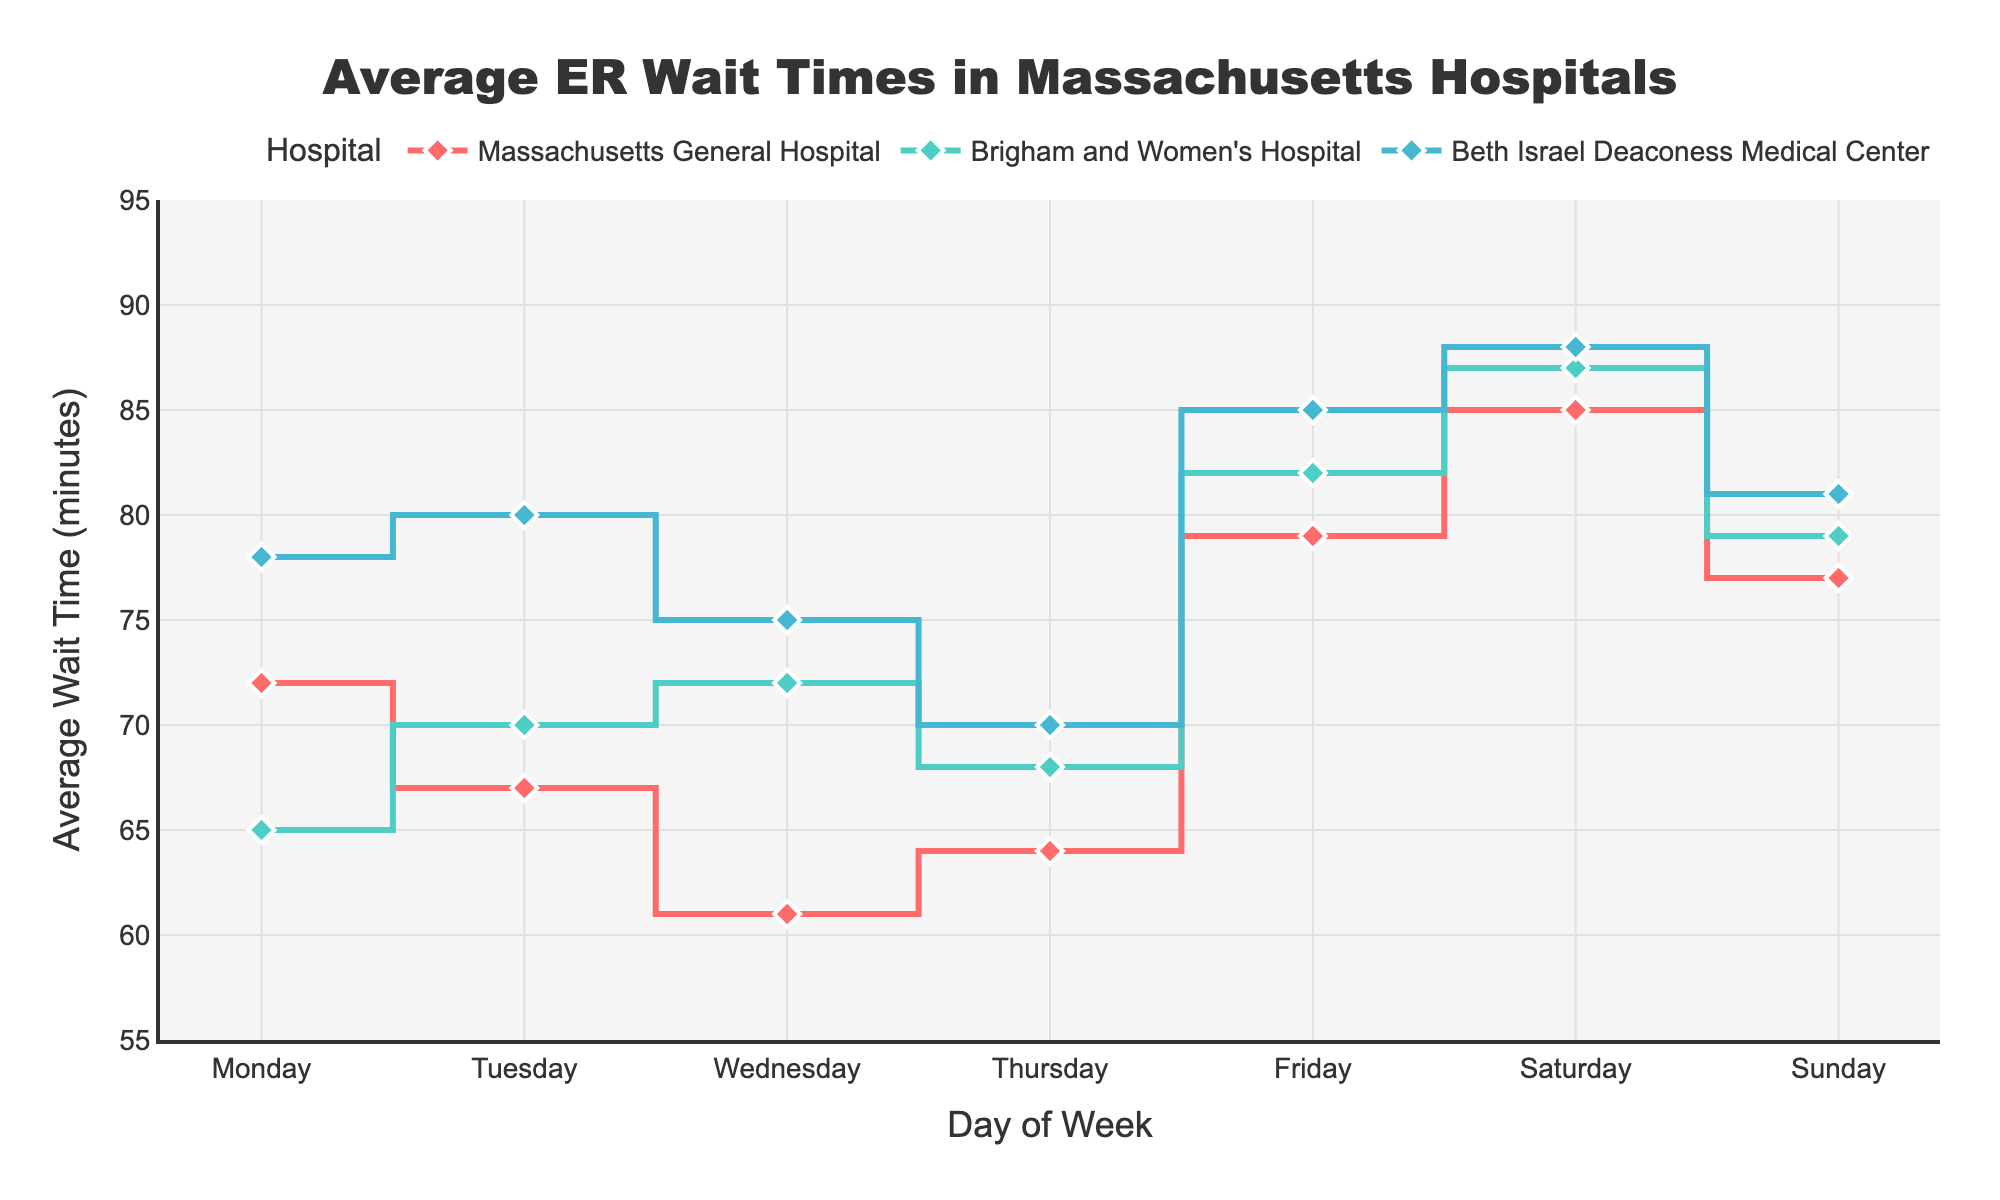What is the title of the plot? The title is typically present at the top center of the chart. In this case, it reads "Average ER Wait Times in Massachusetts Hospitals".
Answer: Average ER Wait Times in Massachusetts Hospitals What does the x-axis represent? The x-axis labels show the days of the week.
Answer: Day of Week Which day has the highest average wait time for Massachusetts General Hospital? Look at the line corresponding to Massachusetts General Hospital and identify the peak. Saturday has the highest point.
Answer: Saturday What color represents Brigham and Women's Hospital? Each hospital has a line of a specific color. Brigham and Women's Hospital is represented by the teal line.
Answer: Teal Which day has the overall highest average wait time across all hospitals? Check the highest points for each line and identify the day. All hospitals peak on Saturday.
Answer: Saturday What is the average wait time for Beth Israel Deaconess Medical Center on Tuesday? Locate the point for Tuesday on the line for Beth Israel Deaconess Medical Center. It is 80 minutes.
Answer: 80 minutes How does the wait time for Brigham and Women's Hospital compare between Thursday and Sunday? Check the height of the points on the teal line for Thursday and Sunday. On Thursday, the wait time is 68 minutes, and on Sunday, it is 79 minutes.
Answer: It increases from 68 minutes to 79 minutes Which hospital has the lowest average wait time on Monday? Compare the points for Monday across all hospitals. Brigham and Women's Hospital has the lowest wait time at 65 minutes.
Answer: Brigham and Women's Hospital How does the wait time for Massachusetts General Hospital change from Wednesday to Friday? Identify the points for Wednesday and Friday. On Wednesday, it is 61 minutes, and on Friday, it increases to 79 minutes.
Answer: It increases from 61 minutes to 79 minutes Which hospital shows the most significant increase in wait times from Wednesday to Friday? Calculate the difference between Wednesday and Friday for all hospitals. For Massachusetts General Hospital, it is 79-61=18 minutes, for Brigham and Women's Hospital, it is 82-72=10 minutes, and for Beth Israel Deaconess Medical Center, it is 85-75=10 minutes. Massachusetts General Hospital shows the most significant increase.
Answer: Massachusetts General Hospital 